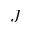<formula> <loc_0><loc_0><loc_500><loc_500>J</formula> 